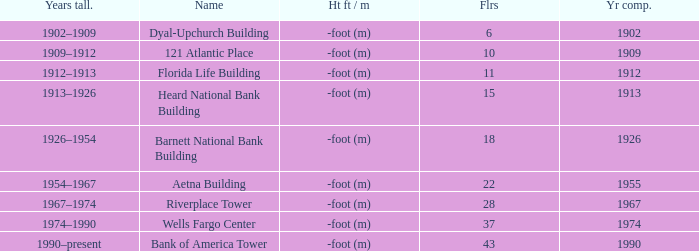What year was the building completed that has 10 floors? 1909.0. 